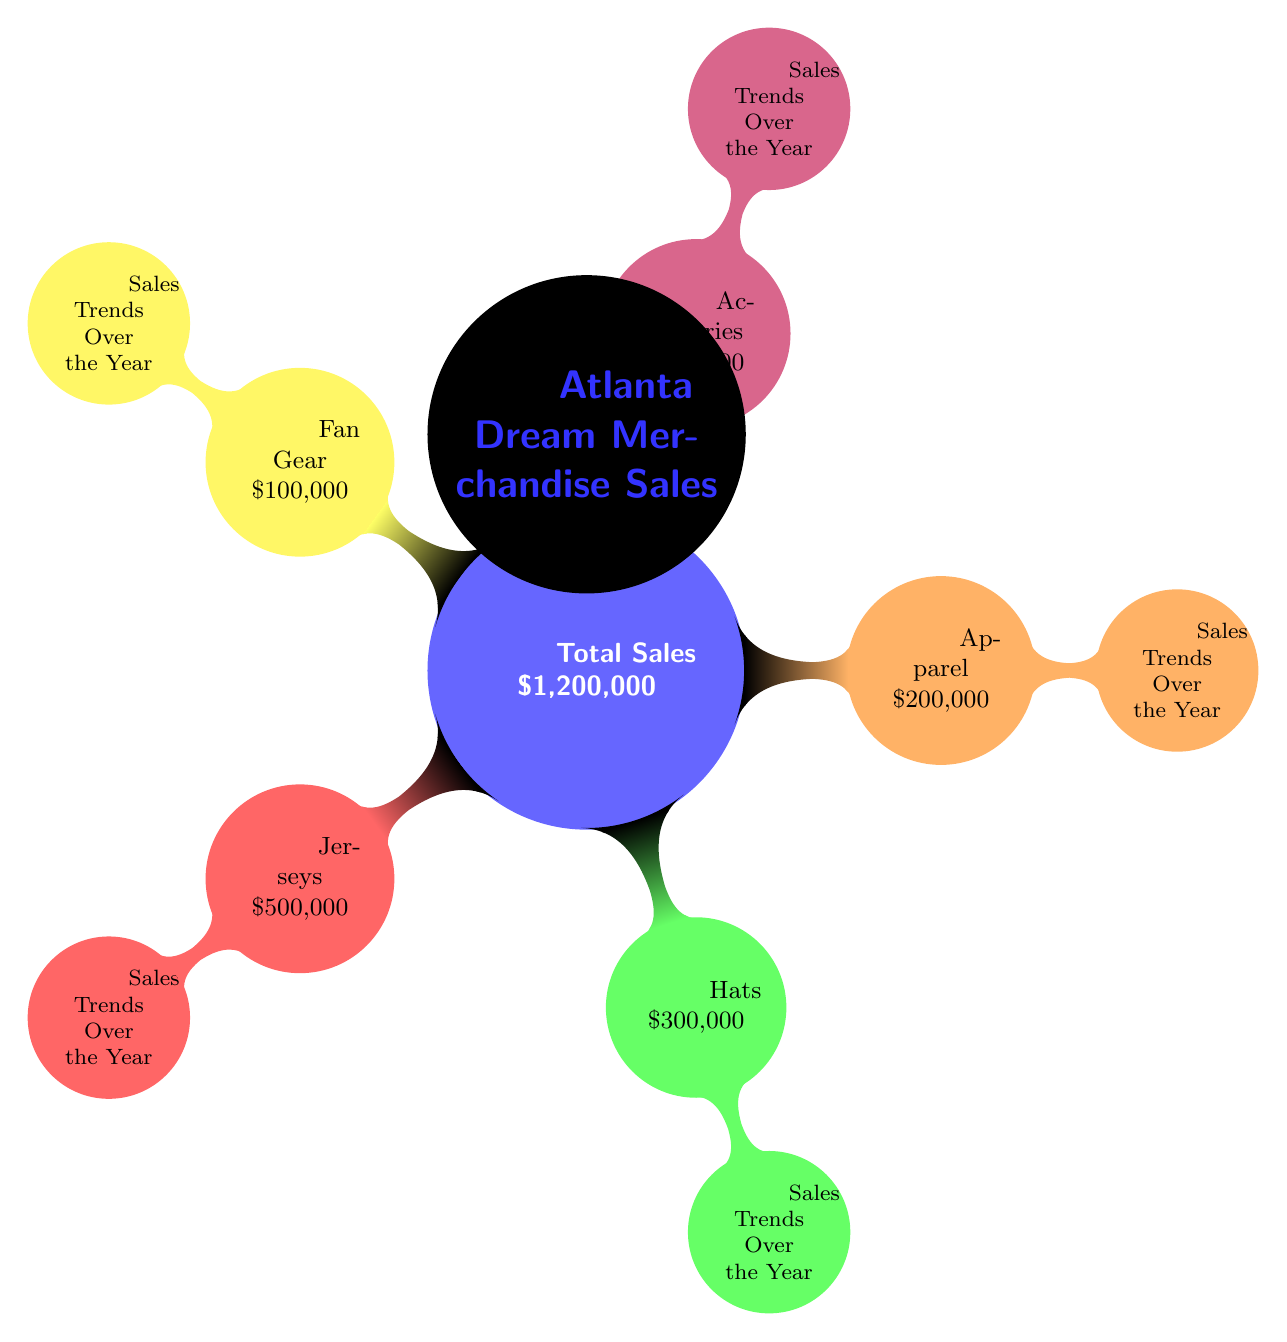What is the total sales amount for Atlanta Dream merchandise? The total sales amount is prominently displayed at the center of the diagram as \$1,200,000.
Answer: \$1,200,000 Which merchandise category has the highest sales? By examining the sales figures for each category, Jerseys have the highest sales at \$500,000, which is the largest amount in the diagram.
Answer: Jerseys How much did Atlanta Dream earn from hats? The diagram indicates that the sales from Hats are \$300,000, specifically shown in the green node labeled Hats.
Answer: \$300,000 What is the total sale amount for accessories and fan gear combined? Accessories total \$100,000 and Fan Gear also totals \$100,000. Adding these amounts together gives \$100,000 + \$100,000 = \$200,000.
Answer: \$200,000 What percentage of total sales do apparel sales represent? Apparel sales total \$200,000, and the total sales amount is \$1,200,000. To find the percentage, the calculation is (200,000 / 1,200,000) * 100 = 16.67%.
Answer: 16.67% How many merchandise categories are represented in the diagram? The nodes represent five categories: Jerseys, Hats, Apparel, Accessories, and Fan Gear. Counting these gives a total of five distinct categories.
Answer: 5 Which category has the lowest sales according to the diagram? By reviewing the sales values, both Accessories and Fan Gear are tied at \$100,000, making them the categories with the lowest sales. Therefore, either could be considered lowest.
Answer: Accessories or Fan Gear What color represents the hats in the diagram? The diagram uses green to represent the Hats category, which is evident from the color coding of the nodes.
Answer: Green What is the node structure type used in this diagram? The diagram's structure is a mind map, as indicated by its design, which shows a central idea with branching nodes to represent related concepts.
Answer: Mind map What unique feature satisfies that this is a Textbook Diagram type? The structured breakdown of merchandise sales and the categorical representation along with sales trends showcases the hierarchical organization typical of a Textbook Diagram.
Answer: Hierarchical organization 